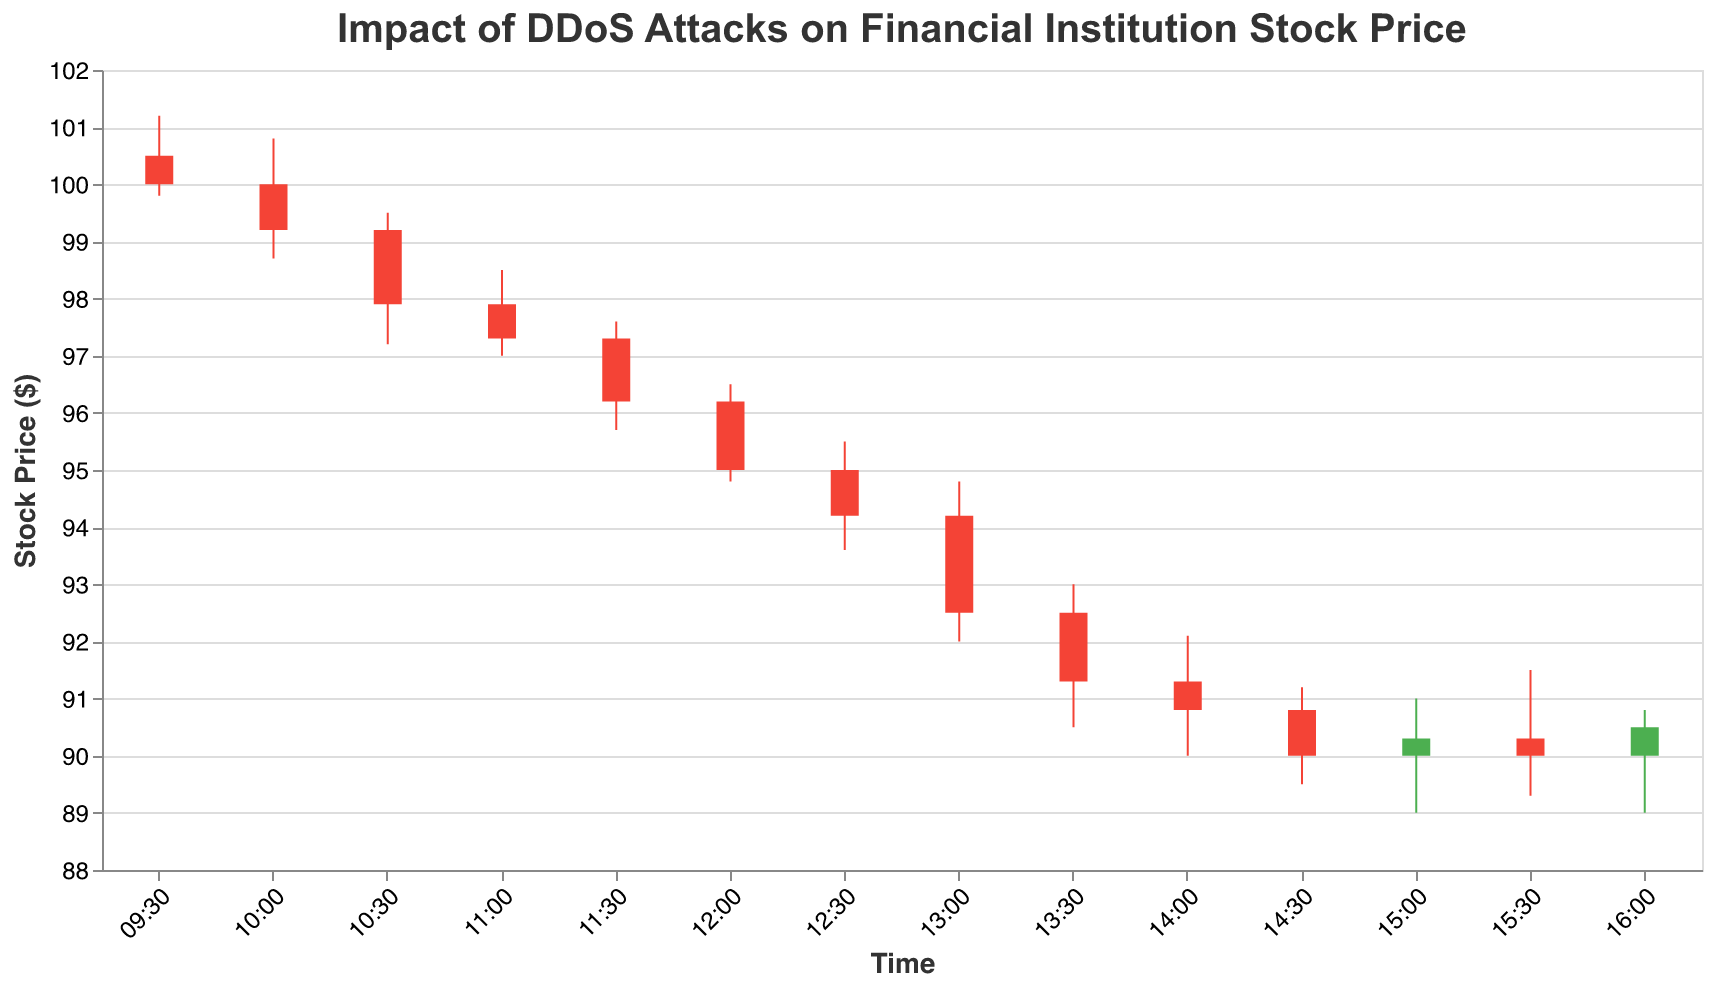What is the highest stock price achieved on October 1st, 2023? The highest price is found at the peak of the stock prices on the y-axis. From the data, the highest value is 101.2, which occurred at 09:30.
Answer: 101.2 How did the stock price change after the minor DDoS attack was reported? The stock price at 11:00 (just after the minor DDoS attack) opened at 97.9 and closed at 97.3. At 11:30, the stock price opened at 97.3 and closed at 96.2. This indicates a decline after the minor attack.
Answer: Decline At what time did the major DDoS attack occur and what was the impact on the closing stock price immediately after? The major DDoS attack was reported at 12:00. Before the attack, the closing price was 96.2 (at 11:30). Immediately after the attack, the closing price was 95.0 (at 12:00).
Answer: 12:00, Decrease to 95.0 What is the difference between the opening and closing prices at 11:00? The opening price at 11:00 was 97.9 and the closing price was 97.3. The difference is 97.9 - 97.3.
Answer: 0.6 Which time interval saw the greatest drop in stock price? By comparing the opening and closing prices of each time interval, the greatest drop is between 13:00 and 13:30 where the stock opened at 94.2 and closed at 91.3, resulting in a drop of 2.9 points.
Answer: 13:00 to 13:30 How did the volume of trades change during the time of the major DDoS attack compared to the minor one? The minor DDoS attack at 11:00 had a volume of 1,000,000 trades. The major DDoS attack at 12:00 had a volume of 1,700,000 trades.
Answer: Increased by 700,000 trades At what time did the stock price first fall below 95? The first time the closing price fell below 95 was at 12:30, with a closing price of 94.2.
Answer: 12:30 What is the trend in stock price from market open to market close on October 1st, 2023? Observing the stock prices from 09:30 to 16:00, the trend shows an overall decline from the opening price at 100.5 to the closing price at 90.5.
Answer: Declining What was the lowest price reached before the major DDoS attack was reported? By examining the prices before 12:00, the lowest price was 95.7 which occurred at 11:30.
Answer: 95.7 How much did the stock price change from the market opening to the closing on October 1st, 2023? The stock opened at 100.5 at 09:30 and closed at 90.5 at 16:00. The change is 100.5 - 90.5.
Answer: 10 